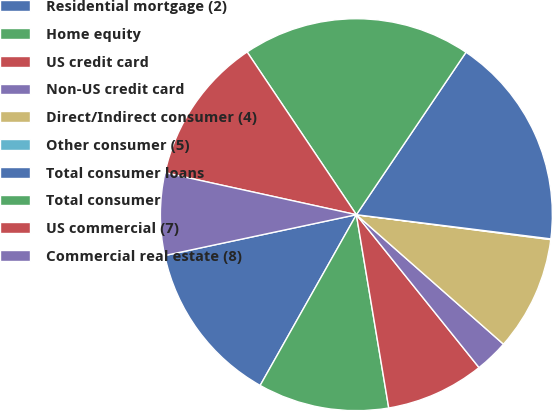<chart> <loc_0><loc_0><loc_500><loc_500><pie_chart><fcel>Residential mortgage (2)<fcel>Home equity<fcel>US credit card<fcel>Non-US credit card<fcel>Direct/Indirect consumer (4)<fcel>Other consumer (5)<fcel>Total consumer loans<fcel>Total consumer<fcel>US commercial (7)<fcel>Commercial real estate (8)<nl><fcel>13.49%<fcel>10.81%<fcel>8.12%<fcel>2.75%<fcel>9.46%<fcel>0.06%<fcel>17.52%<fcel>18.86%<fcel>12.15%<fcel>6.78%<nl></chart> 